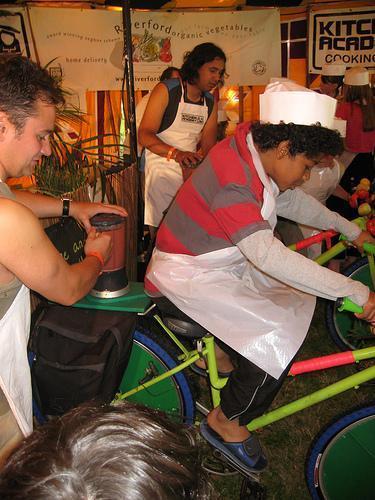How many bikes are there?
Give a very brief answer. 2. 